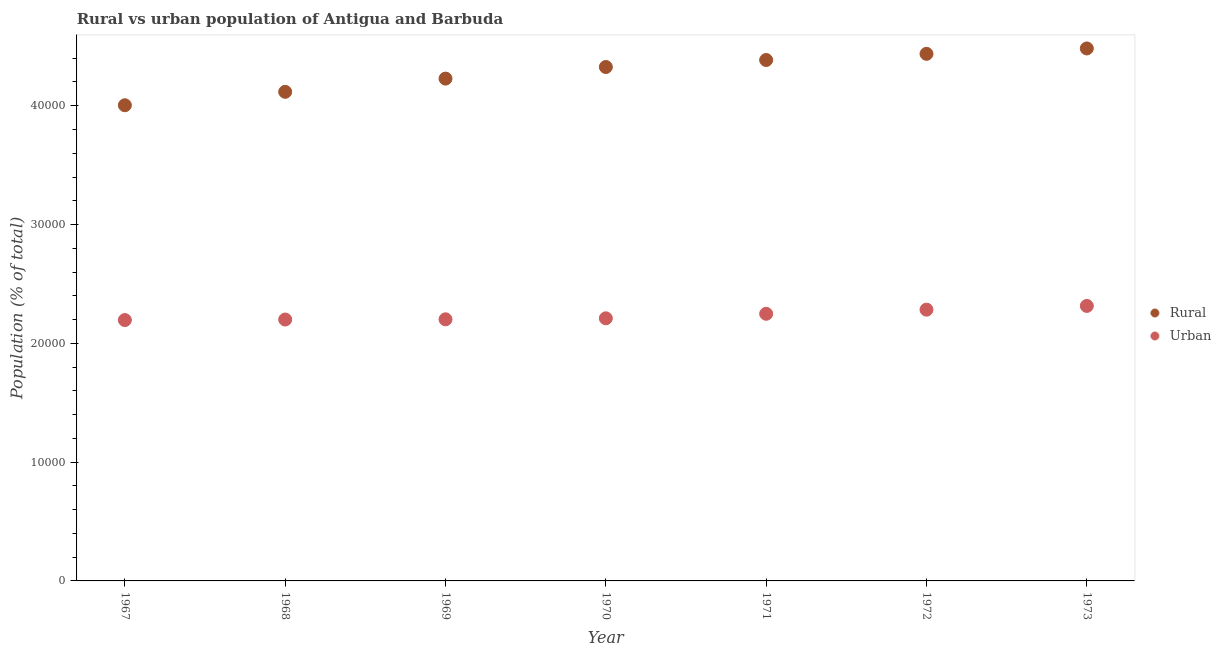Is the number of dotlines equal to the number of legend labels?
Give a very brief answer. Yes. What is the rural population density in 1967?
Offer a terse response. 4.00e+04. Across all years, what is the maximum urban population density?
Provide a succinct answer. 2.31e+04. Across all years, what is the minimum rural population density?
Offer a terse response. 4.00e+04. In which year was the rural population density minimum?
Keep it short and to the point. 1967. What is the total urban population density in the graph?
Provide a succinct answer. 1.57e+05. What is the difference between the urban population density in 1968 and that in 1972?
Your answer should be very brief. -831. What is the difference between the urban population density in 1968 and the rural population density in 1970?
Offer a terse response. -2.13e+04. What is the average rural population density per year?
Make the answer very short. 4.28e+04. In the year 1971, what is the difference between the rural population density and urban population density?
Your answer should be very brief. 2.14e+04. What is the ratio of the urban population density in 1967 to that in 1968?
Give a very brief answer. 1. Is the urban population density in 1972 less than that in 1973?
Offer a terse response. Yes. What is the difference between the highest and the second highest urban population density?
Provide a succinct answer. 314. What is the difference between the highest and the lowest urban population density?
Your answer should be very brief. 1189. How many dotlines are there?
Give a very brief answer. 2. How many years are there in the graph?
Offer a terse response. 7. Does the graph contain any zero values?
Your answer should be very brief. No. How many legend labels are there?
Give a very brief answer. 2. How are the legend labels stacked?
Keep it short and to the point. Vertical. What is the title of the graph?
Give a very brief answer. Rural vs urban population of Antigua and Barbuda. Does "Borrowers" appear as one of the legend labels in the graph?
Ensure brevity in your answer.  No. What is the label or title of the Y-axis?
Ensure brevity in your answer.  Population (% of total). What is the Population (% of total) in Rural in 1967?
Offer a very short reply. 4.00e+04. What is the Population (% of total) of Urban in 1967?
Provide a short and direct response. 2.20e+04. What is the Population (% of total) in Rural in 1968?
Provide a short and direct response. 4.12e+04. What is the Population (% of total) of Urban in 1968?
Provide a succinct answer. 2.20e+04. What is the Population (% of total) in Rural in 1969?
Offer a very short reply. 4.23e+04. What is the Population (% of total) of Urban in 1969?
Provide a succinct answer. 2.20e+04. What is the Population (% of total) of Rural in 1970?
Offer a terse response. 4.33e+04. What is the Population (% of total) of Urban in 1970?
Your answer should be very brief. 2.21e+04. What is the Population (% of total) of Rural in 1971?
Offer a very short reply. 4.39e+04. What is the Population (% of total) in Urban in 1971?
Provide a succinct answer. 2.25e+04. What is the Population (% of total) in Rural in 1972?
Provide a short and direct response. 4.44e+04. What is the Population (% of total) of Urban in 1972?
Give a very brief answer. 2.28e+04. What is the Population (% of total) of Rural in 1973?
Make the answer very short. 4.48e+04. What is the Population (% of total) in Urban in 1973?
Your answer should be compact. 2.31e+04. Across all years, what is the maximum Population (% of total) in Rural?
Ensure brevity in your answer.  4.48e+04. Across all years, what is the maximum Population (% of total) of Urban?
Your answer should be very brief. 2.31e+04. Across all years, what is the minimum Population (% of total) in Rural?
Keep it short and to the point. 4.00e+04. Across all years, what is the minimum Population (% of total) in Urban?
Provide a succinct answer. 2.20e+04. What is the total Population (% of total) of Rural in the graph?
Ensure brevity in your answer.  3.00e+05. What is the total Population (% of total) of Urban in the graph?
Your answer should be compact. 1.57e+05. What is the difference between the Population (% of total) of Rural in 1967 and that in 1968?
Provide a succinct answer. -1130. What is the difference between the Population (% of total) of Urban in 1967 and that in 1968?
Make the answer very short. -44. What is the difference between the Population (% of total) in Rural in 1967 and that in 1969?
Your answer should be very brief. -2243. What is the difference between the Population (% of total) in Urban in 1967 and that in 1969?
Give a very brief answer. -62. What is the difference between the Population (% of total) in Rural in 1967 and that in 1970?
Offer a very short reply. -3220. What is the difference between the Population (% of total) of Urban in 1967 and that in 1970?
Provide a short and direct response. -147. What is the difference between the Population (% of total) in Rural in 1967 and that in 1971?
Offer a terse response. -3809. What is the difference between the Population (% of total) in Urban in 1967 and that in 1971?
Make the answer very short. -527. What is the difference between the Population (% of total) in Rural in 1967 and that in 1972?
Give a very brief answer. -4328. What is the difference between the Population (% of total) in Urban in 1967 and that in 1972?
Give a very brief answer. -875. What is the difference between the Population (% of total) in Rural in 1967 and that in 1973?
Offer a terse response. -4781. What is the difference between the Population (% of total) in Urban in 1967 and that in 1973?
Give a very brief answer. -1189. What is the difference between the Population (% of total) in Rural in 1968 and that in 1969?
Your response must be concise. -1113. What is the difference between the Population (% of total) of Rural in 1968 and that in 1970?
Offer a terse response. -2090. What is the difference between the Population (% of total) of Urban in 1968 and that in 1970?
Your answer should be compact. -103. What is the difference between the Population (% of total) in Rural in 1968 and that in 1971?
Provide a short and direct response. -2679. What is the difference between the Population (% of total) in Urban in 1968 and that in 1971?
Provide a succinct answer. -483. What is the difference between the Population (% of total) in Rural in 1968 and that in 1972?
Keep it short and to the point. -3198. What is the difference between the Population (% of total) of Urban in 1968 and that in 1972?
Offer a terse response. -831. What is the difference between the Population (% of total) in Rural in 1968 and that in 1973?
Offer a terse response. -3651. What is the difference between the Population (% of total) in Urban in 1968 and that in 1973?
Keep it short and to the point. -1145. What is the difference between the Population (% of total) in Rural in 1969 and that in 1970?
Your answer should be very brief. -977. What is the difference between the Population (% of total) of Urban in 1969 and that in 1970?
Your response must be concise. -85. What is the difference between the Population (% of total) in Rural in 1969 and that in 1971?
Your answer should be very brief. -1566. What is the difference between the Population (% of total) of Urban in 1969 and that in 1971?
Your answer should be very brief. -465. What is the difference between the Population (% of total) in Rural in 1969 and that in 1972?
Make the answer very short. -2085. What is the difference between the Population (% of total) in Urban in 1969 and that in 1972?
Give a very brief answer. -813. What is the difference between the Population (% of total) in Rural in 1969 and that in 1973?
Your answer should be very brief. -2538. What is the difference between the Population (% of total) in Urban in 1969 and that in 1973?
Offer a very short reply. -1127. What is the difference between the Population (% of total) of Rural in 1970 and that in 1971?
Offer a very short reply. -589. What is the difference between the Population (% of total) of Urban in 1970 and that in 1971?
Make the answer very short. -380. What is the difference between the Population (% of total) in Rural in 1970 and that in 1972?
Your answer should be compact. -1108. What is the difference between the Population (% of total) in Urban in 1970 and that in 1972?
Provide a succinct answer. -728. What is the difference between the Population (% of total) of Rural in 1970 and that in 1973?
Your answer should be very brief. -1561. What is the difference between the Population (% of total) of Urban in 1970 and that in 1973?
Your answer should be compact. -1042. What is the difference between the Population (% of total) of Rural in 1971 and that in 1972?
Make the answer very short. -519. What is the difference between the Population (% of total) of Urban in 1971 and that in 1972?
Make the answer very short. -348. What is the difference between the Population (% of total) of Rural in 1971 and that in 1973?
Provide a short and direct response. -972. What is the difference between the Population (% of total) in Urban in 1971 and that in 1973?
Your response must be concise. -662. What is the difference between the Population (% of total) in Rural in 1972 and that in 1973?
Your response must be concise. -453. What is the difference between the Population (% of total) in Urban in 1972 and that in 1973?
Your response must be concise. -314. What is the difference between the Population (% of total) in Rural in 1967 and the Population (% of total) in Urban in 1968?
Provide a succinct answer. 1.80e+04. What is the difference between the Population (% of total) in Rural in 1967 and the Population (% of total) in Urban in 1969?
Give a very brief answer. 1.80e+04. What is the difference between the Population (% of total) of Rural in 1967 and the Population (% of total) of Urban in 1970?
Your answer should be very brief. 1.79e+04. What is the difference between the Population (% of total) of Rural in 1967 and the Population (% of total) of Urban in 1971?
Give a very brief answer. 1.76e+04. What is the difference between the Population (% of total) in Rural in 1967 and the Population (% of total) in Urban in 1972?
Offer a terse response. 1.72e+04. What is the difference between the Population (% of total) of Rural in 1967 and the Population (% of total) of Urban in 1973?
Provide a short and direct response. 1.69e+04. What is the difference between the Population (% of total) in Rural in 1968 and the Population (% of total) in Urban in 1969?
Ensure brevity in your answer.  1.92e+04. What is the difference between the Population (% of total) in Rural in 1968 and the Population (% of total) in Urban in 1970?
Offer a terse response. 1.91e+04. What is the difference between the Population (% of total) of Rural in 1968 and the Population (% of total) of Urban in 1971?
Offer a very short reply. 1.87e+04. What is the difference between the Population (% of total) of Rural in 1968 and the Population (% of total) of Urban in 1972?
Your response must be concise. 1.83e+04. What is the difference between the Population (% of total) in Rural in 1968 and the Population (% of total) in Urban in 1973?
Provide a short and direct response. 1.80e+04. What is the difference between the Population (% of total) in Rural in 1969 and the Population (% of total) in Urban in 1970?
Provide a succinct answer. 2.02e+04. What is the difference between the Population (% of total) in Rural in 1969 and the Population (% of total) in Urban in 1971?
Offer a terse response. 1.98e+04. What is the difference between the Population (% of total) in Rural in 1969 and the Population (% of total) in Urban in 1972?
Offer a terse response. 1.94e+04. What is the difference between the Population (% of total) in Rural in 1969 and the Population (% of total) in Urban in 1973?
Your answer should be compact. 1.91e+04. What is the difference between the Population (% of total) in Rural in 1970 and the Population (% of total) in Urban in 1971?
Give a very brief answer. 2.08e+04. What is the difference between the Population (% of total) of Rural in 1970 and the Population (% of total) of Urban in 1972?
Keep it short and to the point. 2.04e+04. What is the difference between the Population (% of total) of Rural in 1970 and the Population (% of total) of Urban in 1973?
Provide a short and direct response. 2.01e+04. What is the difference between the Population (% of total) in Rural in 1971 and the Population (% of total) in Urban in 1972?
Your response must be concise. 2.10e+04. What is the difference between the Population (% of total) in Rural in 1971 and the Population (% of total) in Urban in 1973?
Your response must be concise. 2.07e+04. What is the difference between the Population (% of total) of Rural in 1972 and the Population (% of total) of Urban in 1973?
Your response must be concise. 2.12e+04. What is the average Population (% of total) of Rural per year?
Keep it short and to the point. 4.28e+04. What is the average Population (% of total) in Urban per year?
Give a very brief answer. 2.24e+04. In the year 1967, what is the difference between the Population (% of total) of Rural and Population (% of total) of Urban?
Your answer should be very brief. 1.81e+04. In the year 1968, what is the difference between the Population (% of total) in Rural and Population (% of total) in Urban?
Keep it short and to the point. 1.92e+04. In the year 1969, what is the difference between the Population (% of total) in Rural and Population (% of total) in Urban?
Make the answer very short. 2.03e+04. In the year 1970, what is the difference between the Population (% of total) of Rural and Population (% of total) of Urban?
Give a very brief answer. 2.12e+04. In the year 1971, what is the difference between the Population (% of total) of Rural and Population (% of total) of Urban?
Ensure brevity in your answer.  2.14e+04. In the year 1972, what is the difference between the Population (% of total) of Rural and Population (% of total) of Urban?
Offer a terse response. 2.15e+04. In the year 1973, what is the difference between the Population (% of total) of Rural and Population (% of total) of Urban?
Your answer should be compact. 2.17e+04. What is the ratio of the Population (% of total) in Rural in 1967 to that in 1968?
Provide a short and direct response. 0.97. What is the ratio of the Population (% of total) of Rural in 1967 to that in 1969?
Give a very brief answer. 0.95. What is the ratio of the Population (% of total) of Urban in 1967 to that in 1969?
Your answer should be very brief. 1. What is the ratio of the Population (% of total) of Rural in 1967 to that in 1970?
Your response must be concise. 0.93. What is the ratio of the Population (% of total) of Rural in 1967 to that in 1971?
Provide a short and direct response. 0.91. What is the ratio of the Population (% of total) of Urban in 1967 to that in 1971?
Offer a terse response. 0.98. What is the ratio of the Population (% of total) in Rural in 1967 to that in 1972?
Give a very brief answer. 0.9. What is the ratio of the Population (% of total) in Urban in 1967 to that in 1972?
Provide a short and direct response. 0.96. What is the ratio of the Population (% of total) in Rural in 1967 to that in 1973?
Your answer should be compact. 0.89. What is the ratio of the Population (% of total) of Urban in 1967 to that in 1973?
Make the answer very short. 0.95. What is the ratio of the Population (% of total) in Rural in 1968 to that in 1969?
Make the answer very short. 0.97. What is the ratio of the Population (% of total) of Rural in 1968 to that in 1970?
Offer a very short reply. 0.95. What is the ratio of the Population (% of total) of Rural in 1968 to that in 1971?
Keep it short and to the point. 0.94. What is the ratio of the Population (% of total) in Urban in 1968 to that in 1971?
Give a very brief answer. 0.98. What is the ratio of the Population (% of total) of Rural in 1968 to that in 1972?
Your response must be concise. 0.93. What is the ratio of the Population (% of total) of Urban in 1968 to that in 1972?
Your answer should be compact. 0.96. What is the ratio of the Population (% of total) in Rural in 1968 to that in 1973?
Provide a succinct answer. 0.92. What is the ratio of the Population (% of total) of Urban in 1968 to that in 1973?
Give a very brief answer. 0.95. What is the ratio of the Population (% of total) of Rural in 1969 to that in 1970?
Your response must be concise. 0.98. What is the ratio of the Population (% of total) in Rural in 1969 to that in 1971?
Make the answer very short. 0.96. What is the ratio of the Population (% of total) of Urban in 1969 to that in 1971?
Offer a very short reply. 0.98. What is the ratio of the Population (% of total) in Rural in 1969 to that in 1972?
Keep it short and to the point. 0.95. What is the ratio of the Population (% of total) in Urban in 1969 to that in 1972?
Make the answer very short. 0.96. What is the ratio of the Population (% of total) in Rural in 1969 to that in 1973?
Your answer should be very brief. 0.94. What is the ratio of the Population (% of total) in Urban in 1969 to that in 1973?
Your answer should be very brief. 0.95. What is the ratio of the Population (% of total) in Rural in 1970 to that in 1971?
Your response must be concise. 0.99. What is the ratio of the Population (% of total) in Urban in 1970 to that in 1971?
Provide a succinct answer. 0.98. What is the ratio of the Population (% of total) in Urban in 1970 to that in 1972?
Offer a very short reply. 0.97. What is the ratio of the Population (% of total) in Rural in 1970 to that in 1973?
Your answer should be compact. 0.97. What is the ratio of the Population (% of total) of Urban in 1970 to that in 1973?
Your answer should be very brief. 0.95. What is the ratio of the Population (% of total) of Rural in 1971 to that in 1972?
Give a very brief answer. 0.99. What is the ratio of the Population (% of total) in Urban in 1971 to that in 1972?
Your response must be concise. 0.98. What is the ratio of the Population (% of total) in Rural in 1971 to that in 1973?
Offer a very short reply. 0.98. What is the ratio of the Population (% of total) in Urban in 1971 to that in 1973?
Your response must be concise. 0.97. What is the ratio of the Population (% of total) in Urban in 1972 to that in 1973?
Give a very brief answer. 0.99. What is the difference between the highest and the second highest Population (% of total) in Rural?
Make the answer very short. 453. What is the difference between the highest and the second highest Population (% of total) in Urban?
Keep it short and to the point. 314. What is the difference between the highest and the lowest Population (% of total) of Rural?
Your answer should be very brief. 4781. What is the difference between the highest and the lowest Population (% of total) in Urban?
Give a very brief answer. 1189. 